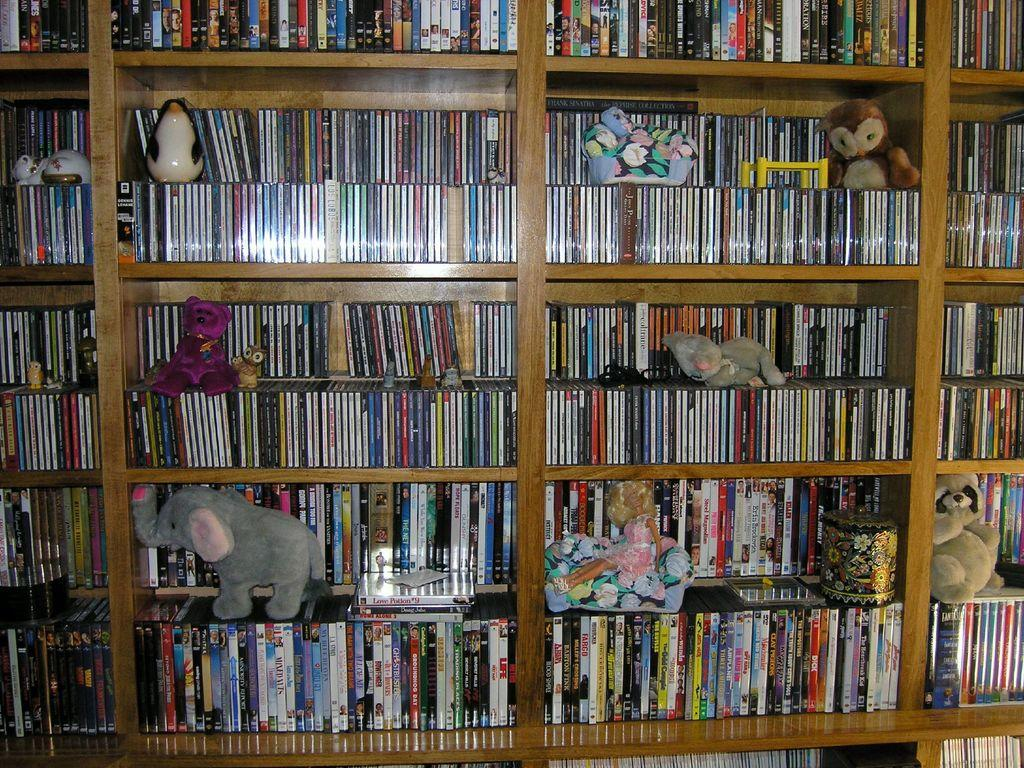What type of items can be seen in the image? There are books and toys in the image. Are there any other objects visible in the image? Yes, there are other objects arranged in a rack in the image. What type of twig is being used to hold up the books in the image? There is no twig present in the image; the books are not being held up by any visible support. 